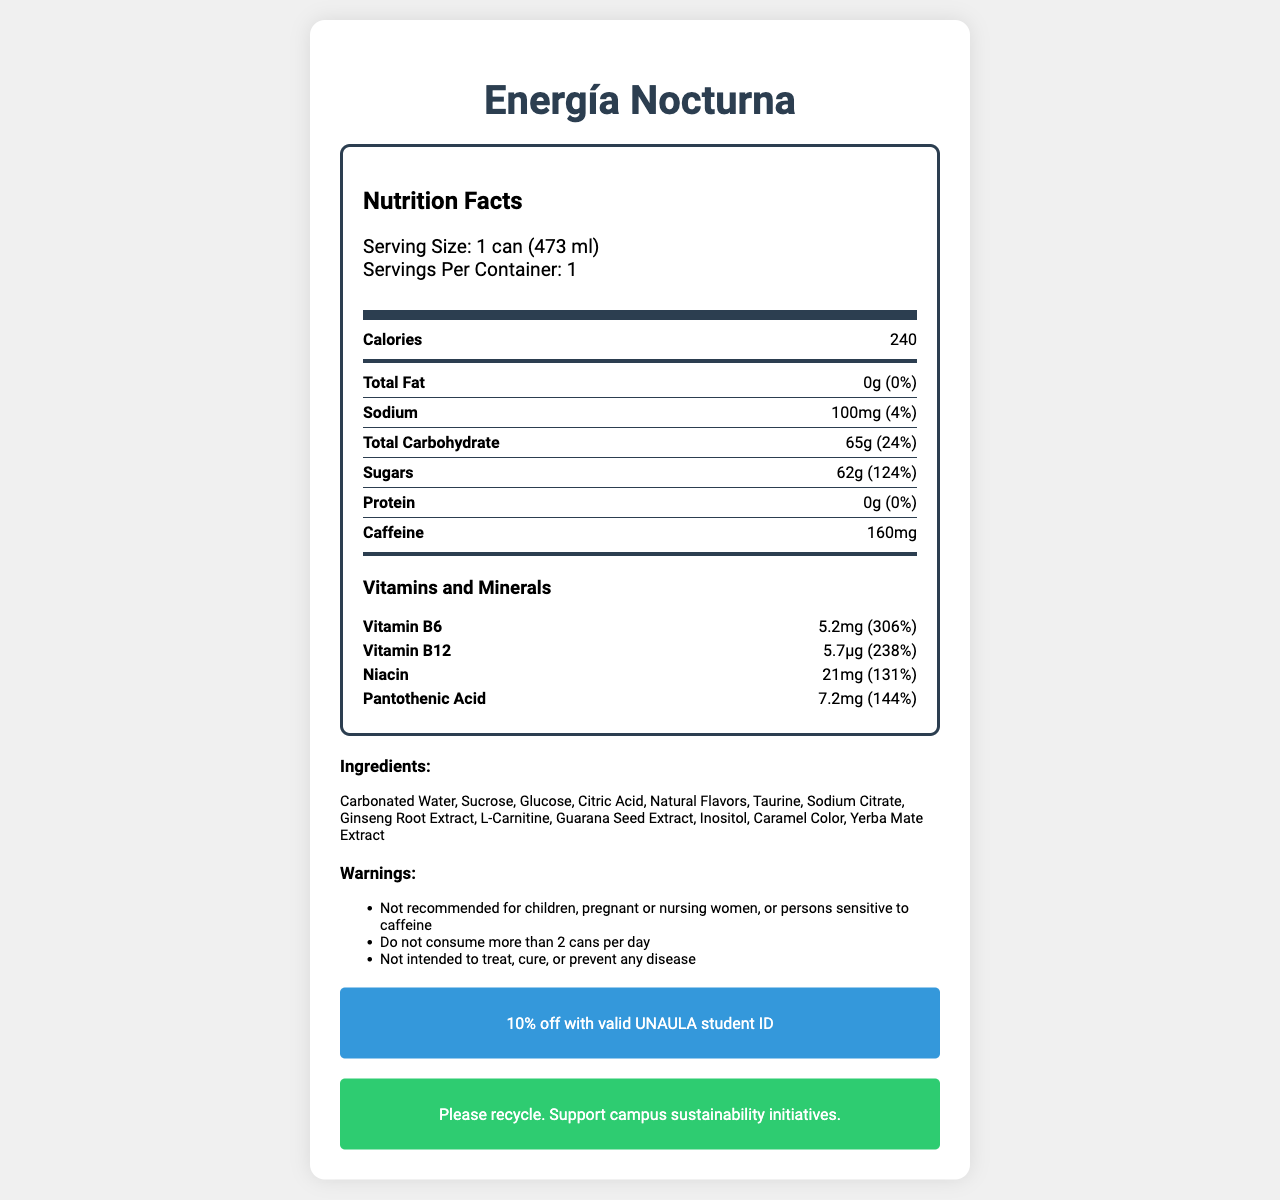What is the serving size for "Energía Nocturna"? The serving size is clearly listed at the top of the nutrition label as "1 can (473 ml)".
Answer: 1 can (473 ml) How many calories are in one serving of "Energía Nocturna"? The number of calories per serving is prominently displayed on the label as 240 calories.
Answer: 240 What is the total carbohydrate amount in "Energía Nocturna"? The total carbohydrate amount is specified as 65g on the nutrition label.
Answer: 65g What is the percentage Daily Value of sugars in "Energía Nocturna"? The percentage Daily Value of sugars is listed as 124% on the nutrition label.
Answer: 124% What amount of sodium does one can of "Energía Nocturna" contain? The amount of sodium per can is listed as 100mg on the label.
Answer: 100mg How much caffeine is in "Energía Nocturna"? The caffeine content is clearly noted as 160mg on the nutrition label.
Answer: 160mg Which of the following is NOT an ingredient in "Energía Nocturna"? 
A. Yerba Mate Extract 
B. Aspartame 
C. Citric Acid Aspartame is not listed among the ingredients in "Energía Nocturna"; other two are present.
Answer: B. Aspartame What is the percentage of the Daily Value of Vitamin B12 in "Energía Nocturna"? 
A. 200%
B. 238%
C. 300%
D. 150% The label indicates that the percentage of the Daily Value of Vitamin B12 is 238%.
Answer: B. 238% Is "Energía Nocturna" suitable for children? The warnings section explicitly states "Not recommended for children".
Answer: No How many vitamins and minerals are listed on the "Energía Nocturna" nutrition label? The label lists four specific vitamins and minerals: Vitamin B6, Vitamin B12, Niacin, and Pantothenic Acid.
Answer: Four Provide a summary of the "Energía Nocturna" nutrition facts label. This summary encapsulates key nutritional information, ingredient list, warnings, and additional consumer information provided on the label.
Answer: The "Energía Nocturna" nutrition facts label details the nutritional content of one can (473 ml), which includes 240 calories, 0g total fat, 100mg sodium, 65g total carbohydrates, 62g sugars, and 160mg caffeine. It also provides information on vitamins and minerals present, such as Vitamin B6 (306% DV), Vitamin B12 (238% DV), Niacin (131% DV), and Pantothenic Acid (144% DV). The label lists myriad ingredients and includes warnings, recycling information, and a special student discount offer for UNAULA students. Where are "Energía Nocturna" energy drinks manufactured? The manufacturer address is listed as Medellín, Colombia on the label.
Answer: Medellín, Colombia Is the caffeine amount in "Energía Nocturna" specified as a percentage of the Daily Value? The caffeine amount is provided, but there is no Daily Value percentage listed for caffeine on the label.
Answer: No What is the website for "Energía Nocturna"? The website is listed at the bottom of the label as www.energianocturna.com.
Answer: www.energianocturna.com What is the level of protein in "Energía Nocturna"? The nutrition label specifies that the amount of protein per serving is 0g.
Answer: 0g Do you have enough information to determine the shelf life of "Energía Nocturna"? The document does not provide any information regarding the shelf life of the energy drink.
Answer: No 